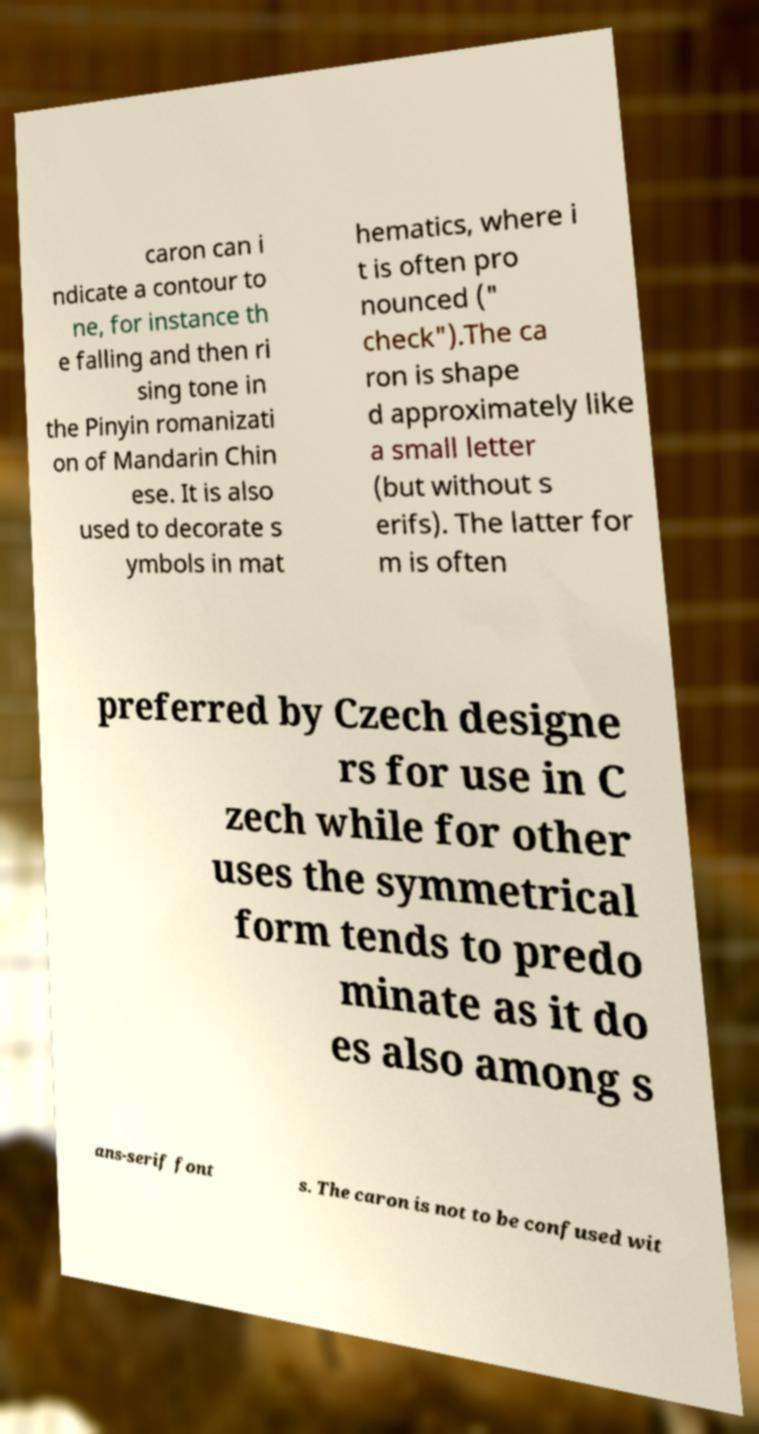There's text embedded in this image that I need extracted. Can you transcribe it verbatim? caron can i ndicate a contour to ne, for instance th e falling and then ri sing tone in the Pinyin romanizati on of Mandarin Chin ese. It is also used to decorate s ymbols in mat hematics, where i t is often pro nounced (" check").The ca ron is shape d approximately like a small letter (but without s erifs). The latter for m is often preferred by Czech designe rs for use in C zech while for other uses the symmetrical form tends to predo minate as it do es also among s ans-serif font s. The caron is not to be confused wit 